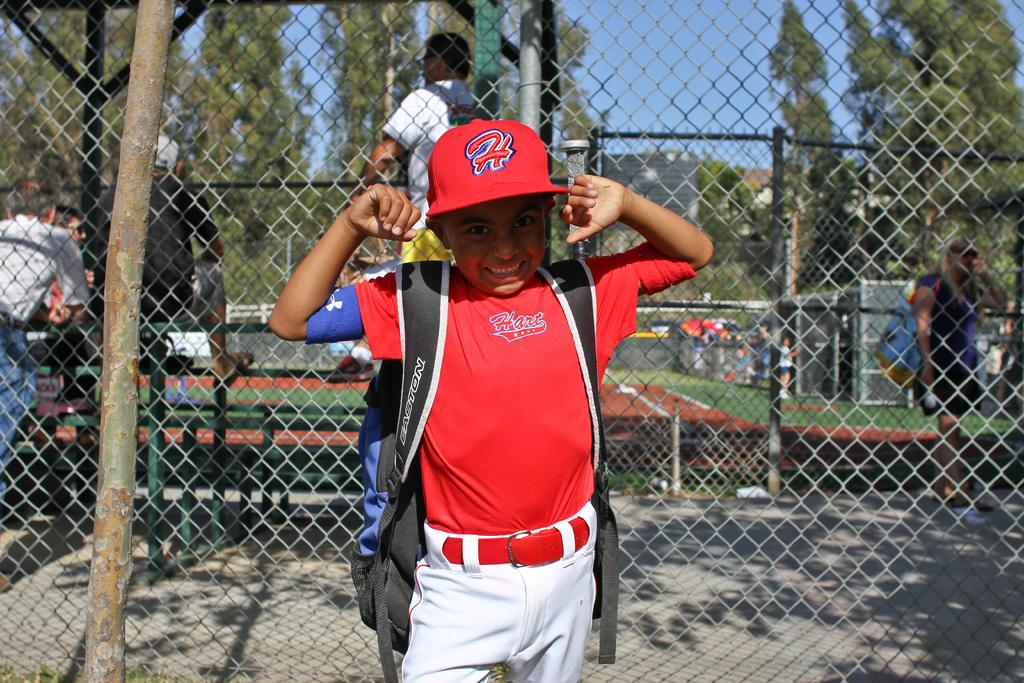<image>
Write a terse but informative summary of the picture. Hart logo on a uniform and H logo on a red cap. 